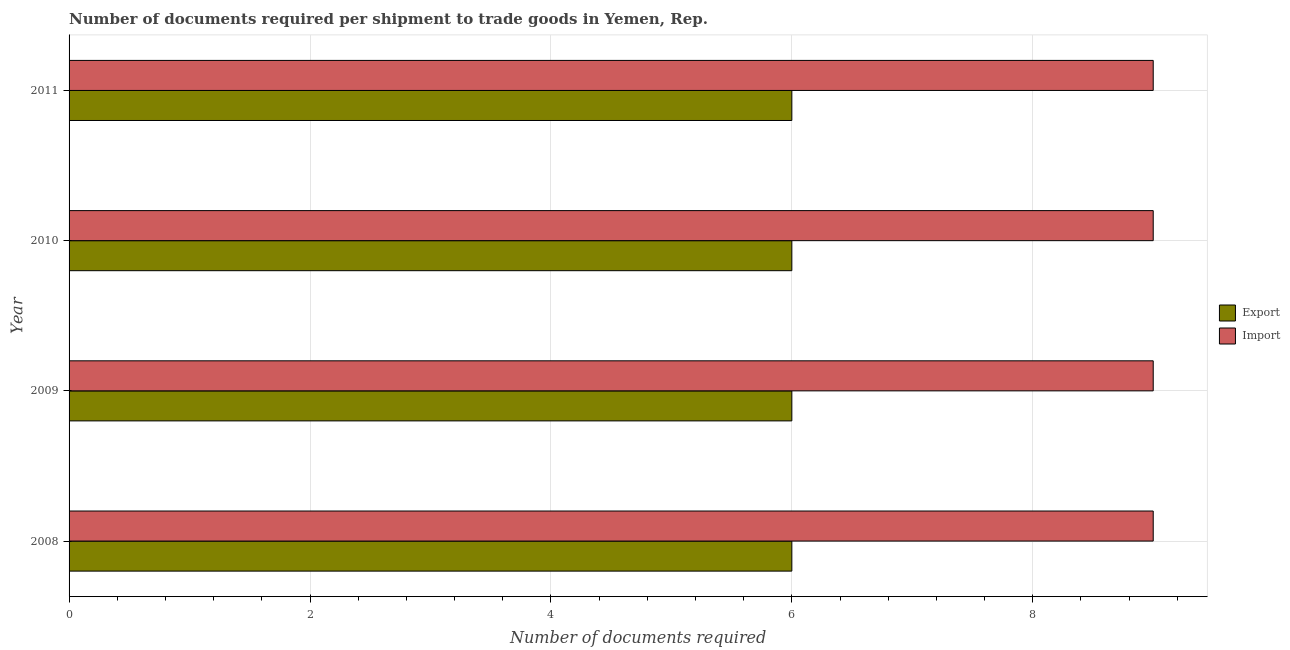How many different coloured bars are there?
Offer a terse response. 2. How many groups of bars are there?
Give a very brief answer. 4. Are the number of bars per tick equal to the number of legend labels?
Ensure brevity in your answer.  Yes. How many bars are there on the 2nd tick from the bottom?
Offer a terse response. 2. What is the label of the 4th group of bars from the top?
Your response must be concise. 2008. What is the number of documents required to export goods in 2010?
Ensure brevity in your answer.  6. Across all years, what is the maximum number of documents required to export goods?
Make the answer very short. 6. Across all years, what is the minimum number of documents required to export goods?
Provide a short and direct response. 6. What is the total number of documents required to export goods in the graph?
Ensure brevity in your answer.  24. What is the difference between the number of documents required to import goods in 2008 and that in 2011?
Your answer should be compact. 0. What is the difference between the number of documents required to export goods in 2008 and the number of documents required to import goods in 2011?
Make the answer very short. -3. What is the average number of documents required to export goods per year?
Give a very brief answer. 6. In the year 2011, what is the difference between the number of documents required to import goods and number of documents required to export goods?
Make the answer very short. 3. In how many years, is the number of documents required to import goods greater than 6 ?
Provide a succinct answer. 4. What is the ratio of the number of documents required to export goods in 2008 to that in 2010?
Make the answer very short. 1. Is the difference between the number of documents required to import goods in 2009 and 2010 greater than the difference between the number of documents required to export goods in 2009 and 2010?
Ensure brevity in your answer.  No. What is the difference between the highest and the second highest number of documents required to import goods?
Give a very brief answer. 0. In how many years, is the number of documents required to export goods greater than the average number of documents required to export goods taken over all years?
Your response must be concise. 0. What does the 1st bar from the top in 2009 represents?
Give a very brief answer. Import. What does the 1st bar from the bottom in 2011 represents?
Your answer should be compact. Export. Are all the bars in the graph horizontal?
Make the answer very short. Yes. How many years are there in the graph?
Your answer should be compact. 4. Are the values on the major ticks of X-axis written in scientific E-notation?
Make the answer very short. No. Where does the legend appear in the graph?
Ensure brevity in your answer.  Center right. How many legend labels are there?
Keep it short and to the point. 2. What is the title of the graph?
Your response must be concise. Number of documents required per shipment to trade goods in Yemen, Rep. What is the label or title of the X-axis?
Your answer should be very brief. Number of documents required. What is the Number of documents required of Export in 2008?
Your answer should be very brief. 6. What is the Number of documents required of Import in 2009?
Make the answer very short. 9. What is the Number of documents required in Export in 2010?
Your answer should be compact. 6. What is the Number of documents required in Import in 2010?
Offer a terse response. 9. What is the Number of documents required in Import in 2011?
Make the answer very short. 9. Across all years, what is the maximum Number of documents required in Import?
Your answer should be compact. 9. What is the difference between the Number of documents required in Export in 2008 and that in 2009?
Your response must be concise. 0. What is the difference between the Number of documents required of Import in 2008 and that in 2009?
Give a very brief answer. 0. What is the difference between the Number of documents required in Import in 2008 and that in 2010?
Provide a succinct answer. 0. What is the difference between the Number of documents required of Export in 2009 and that in 2010?
Offer a very short reply. 0. What is the difference between the Number of documents required in Export in 2009 and that in 2011?
Your response must be concise. 0. What is the difference between the Number of documents required of Export in 2010 and that in 2011?
Keep it short and to the point. 0. What is the difference between the Number of documents required of Import in 2010 and that in 2011?
Provide a succinct answer. 0. What is the difference between the Number of documents required in Export in 2008 and the Number of documents required in Import in 2011?
Provide a short and direct response. -3. What is the difference between the Number of documents required of Export in 2009 and the Number of documents required of Import in 2011?
Provide a short and direct response. -3. What is the difference between the Number of documents required in Export in 2010 and the Number of documents required in Import in 2011?
Your response must be concise. -3. What is the average Number of documents required of Export per year?
Ensure brevity in your answer.  6. What is the average Number of documents required of Import per year?
Give a very brief answer. 9. In the year 2009, what is the difference between the Number of documents required in Export and Number of documents required in Import?
Make the answer very short. -3. In the year 2010, what is the difference between the Number of documents required of Export and Number of documents required of Import?
Provide a succinct answer. -3. In the year 2011, what is the difference between the Number of documents required of Export and Number of documents required of Import?
Offer a very short reply. -3. What is the ratio of the Number of documents required of Export in 2008 to that in 2009?
Provide a succinct answer. 1. What is the ratio of the Number of documents required of Import in 2008 to that in 2009?
Offer a very short reply. 1. What is the ratio of the Number of documents required in Import in 2008 to that in 2010?
Provide a succinct answer. 1. What is the ratio of the Number of documents required in Export in 2008 to that in 2011?
Give a very brief answer. 1. What is the ratio of the Number of documents required in Import in 2008 to that in 2011?
Offer a very short reply. 1. What is the ratio of the Number of documents required of Export in 2009 to that in 2010?
Your response must be concise. 1. What is the ratio of the Number of documents required of Import in 2009 to that in 2010?
Ensure brevity in your answer.  1. What is the ratio of the Number of documents required of Export in 2010 to that in 2011?
Offer a terse response. 1. What is the ratio of the Number of documents required in Import in 2010 to that in 2011?
Offer a terse response. 1. What is the difference between the highest and the second highest Number of documents required in Export?
Provide a succinct answer. 0. What is the difference between the highest and the second highest Number of documents required in Import?
Keep it short and to the point. 0. 